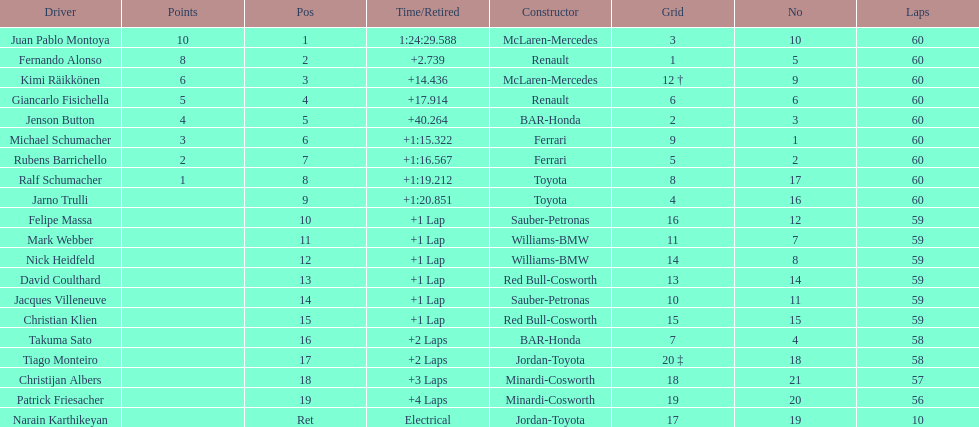Which driver has his grid at 2? Jenson Button. Give me the full table as a dictionary. {'header': ['Driver', 'Points', 'Pos', 'Time/Retired', 'Constructor', 'Grid', 'No', 'Laps'], 'rows': [['Juan Pablo Montoya', '10', '1', '1:24:29.588', 'McLaren-Mercedes', '3', '10', '60'], ['Fernando Alonso', '8', '2', '+2.739', 'Renault', '1', '5', '60'], ['Kimi Räikkönen', '6', '3', '+14.436', 'McLaren-Mercedes', '12 †', '9', '60'], ['Giancarlo Fisichella', '5', '4', '+17.914', 'Renault', '6', '6', '60'], ['Jenson Button', '4', '5', '+40.264', 'BAR-Honda', '2', '3', '60'], ['Michael Schumacher', '3', '6', '+1:15.322', 'Ferrari', '9', '1', '60'], ['Rubens Barrichello', '2', '7', '+1:16.567', 'Ferrari', '5', '2', '60'], ['Ralf Schumacher', '1', '8', '+1:19.212', 'Toyota', '8', '17', '60'], ['Jarno Trulli', '', '9', '+1:20.851', 'Toyota', '4', '16', '60'], ['Felipe Massa', '', '10', '+1 Lap', 'Sauber-Petronas', '16', '12', '59'], ['Mark Webber', '', '11', '+1 Lap', 'Williams-BMW', '11', '7', '59'], ['Nick Heidfeld', '', '12', '+1 Lap', 'Williams-BMW', '14', '8', '59'], ['David Coulthard', '', '13', '+1 Lap', 'Red Bull-Cosworth', '13', '14', '59'], ['Jacques Villeneuve', '', '14', '+1 Lap', 'Sauber-Petronas', '10', '11', '59'], ['Christian Klien', '', '15', '+1 Lap', 'Red Bull-Cosworth', '15', '15', '59'], ['Takuma Sato', '', '16', '+2 Laps', 'BAR-Honda', '7', '4', '58'], ['Tiago Monteiro', '', '17', '+2 Laps', 'Jordan-Toyota', '20 ‡', '18', '58'], ['Christijan Albers', '', '18', '+3 Laps', 'Minardi-Cosworth', '18', '21', '57'], ['Patrick Friesacher', '', '19', '+4 Laps', 'Minardi-Cosworth', '19', '20', '56'], ['Narain Karthikeyan', '', 'Ret', 'Electrical', 'Jordan-Toyota', '17', '19', '10']]} 